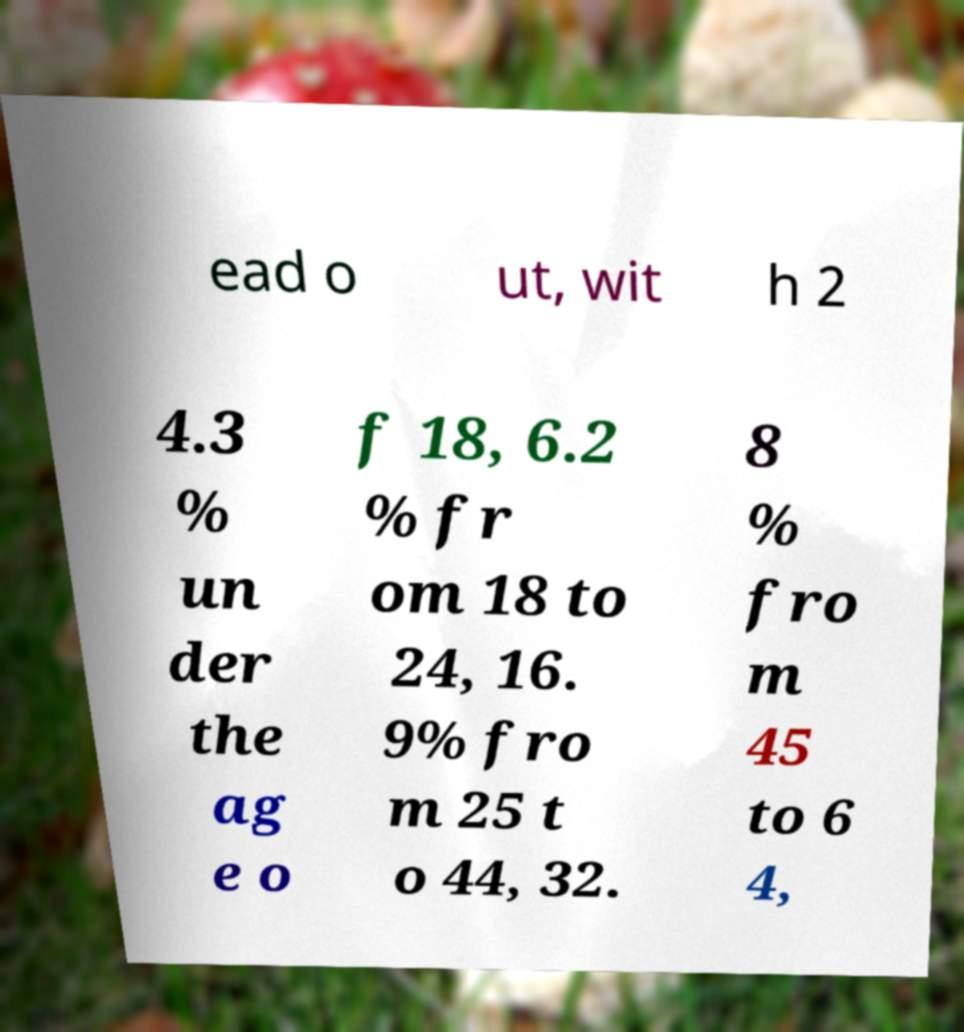Can you read and provide the text displayed in the image?This photo seems to have some interesting text. Can you extract and type it out for me? ead o ut, wit h 2 4.3 % un der the ag e o f 18, 6.2 % fr om 18 to 24, 16. 9% fro m 25 t o 44, 32. 8 % fro m 45 to 6 4, 